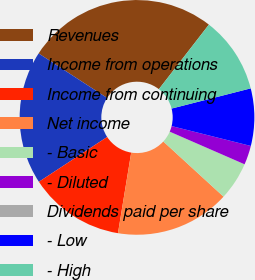<chart> <loc_0><loc_0><loc_500><loc_500><pie_chart><fcel>Revenues<fcel>Income from operations<fcel>Income from continuing<fcel>Net income<fcel>- Basic<fcel>- Diluted<fcel>Dividends paid per share<fcel>- Low<fcel>- High<nl><fcel>26.32%<fcel>18.42%<fcel>13.16%<fcel>15.79%<fcel>5.26%<fcel>2.63%<fcel>0.0%<fcel>7.89%<fcel>10.53%<nl></chart> 